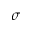Convert formula to latex. <formula><loc_0><loc_0><loc_500><loc_500>\sigma</formula> 